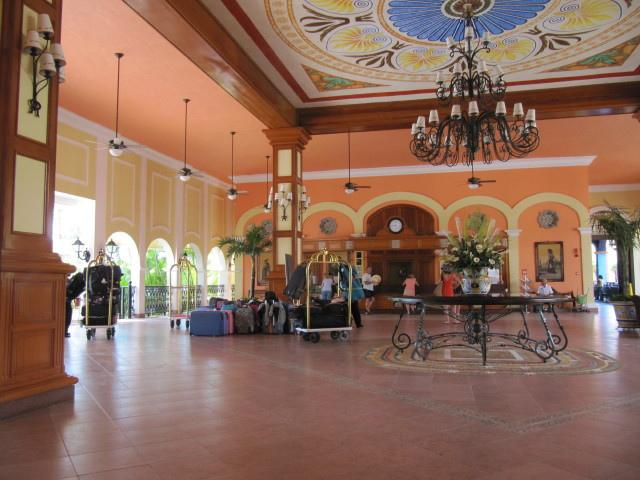What staff member is responsible for pushing the suitcase carts? bellhop 